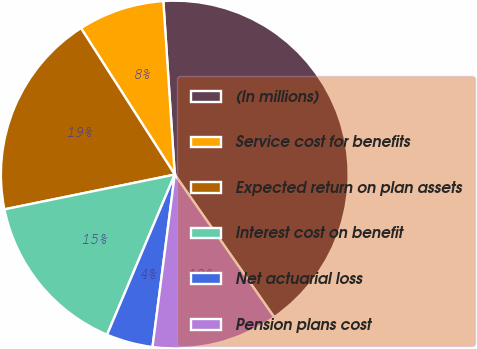Convert chart. <chart><loc_0><loc_0><loc_500><loc_500><pie_chart><fcel>(In millions)<fcel>Service cost for benefits<fcel>Expected return on plan assets<fcel>Interest cost on benefit<fcel>Net actuarial loss<fcel>Pension plans cost<nl><fcel>41.36%<fcel>8.02%<fcel>19.14%<fcel>15.43%<fcel>4.32%<fcel>11.73%<nl></chart> 